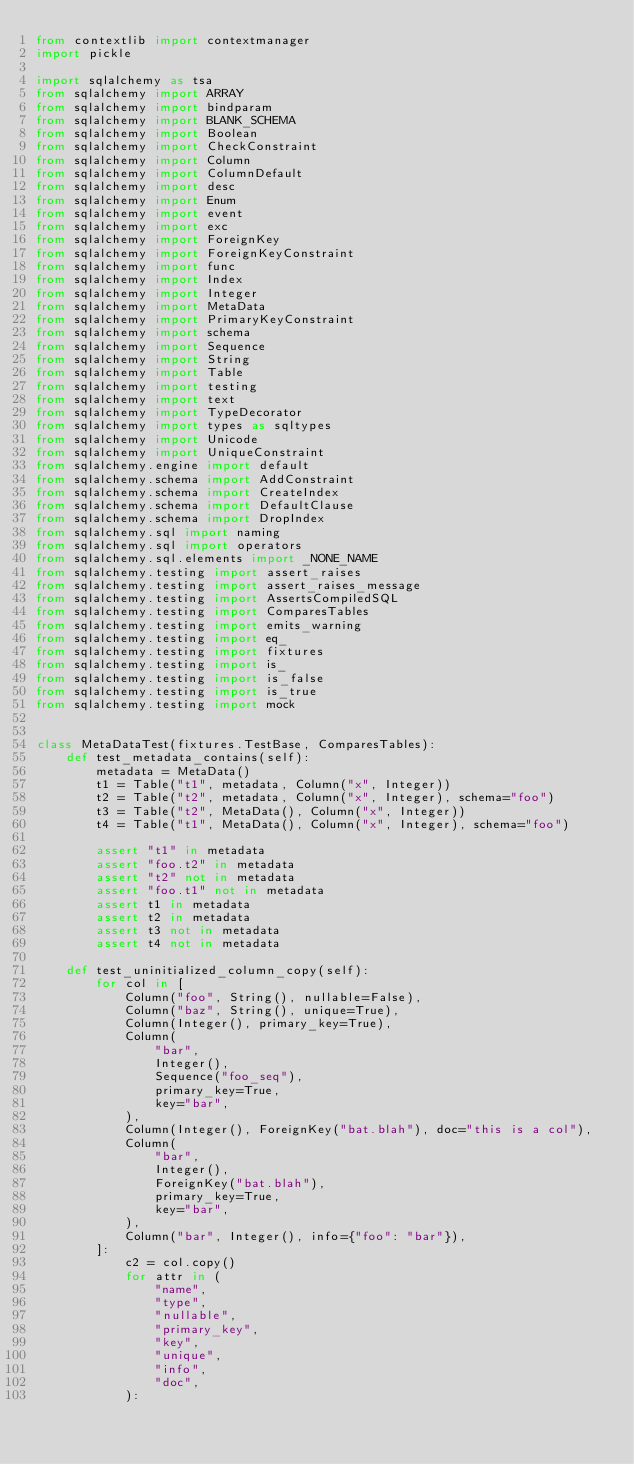<code> <loc_0><loc_0><loc_500><loc_500><_Python_>from contextlib import contextmanager
import pickle

import sqlalchemy as tsa
from sqlalchemy import ARRAY
from sqlalchemy import bindparam
from sqlalchemy import BLANK_SCHEMA
from sqlalchemy import Boolean
from sqlalchemy import CheckConstraint
from sqlalchemy import Column
from sqlalchemy import ColumnDefault
from sqlalchemy import desc
from sqlalchemy import Enum
from sqlalchemy import event
from sqlalchemy import exc
from sqlalchemy import ForeignKey
from sqlalchemy import ForeignKeyConstraint
from sqlalchemy import func
from sqlalchemy import Index
from sqlalchemy import Integer
from sqlalchemy import MetaData
from sqlalchemy import PrimaryKeyConstraint
from sqlalchemy import schema
from sqlalchemy import Sequence
from sqlalchemy import String
from sqlalchemy import Table
from sqlalchemy import testing
from sqlalchemy import text
from sqlalchemy import TypeDecorator
from sqlalchemy import types as sqltypes
from sqlalchemy import Unicode
from sqlalchemy import UniqueConstraint
from sqlalchemy.engine import default
from sqlalchemy.schema import AddConstraint
from sqlalchemy.schema import CreateIndex
from sqlalchemy.schema import DefaultClause
from sqlalchemy.schema import DropIndex
from sqlalchemy.sql import naming
from sqlalchemy.sql import operators
from sqlalchemy.sql.elements import _NONE_NAME
from sqlalchemy.testing import assert_raises
from sqlalchemy.testing import assert_raises_message
from sqlalchemy.testing import AssertsCompiledSQL
from sqlalchemy.testing import ComparesTables
from sqlalchemy.testing import emits_warning
from sqlalchemy.testing import eq_
from sqlalchemy.testing import fixtures
from sqlalchemy.testing import is_
from sqlalchemy.testing import is_false
from sqlalchemy.testing import is_true
from sqlalchemy.testing import mock


class MetaDataTest(fixtures.TestBase, ComparesTables):
    def test_metadata_contains(self):
        metadata = MetaData()
        t1 = Table("t1", metadata, Column("x", Integer))
        t2 = Table("t2", metadata, Column("x", Integer), schema="foo")
        t3 = Table("t2", MetaData(), Column("x", Integer))
        t4 = Table("t1", MetaData(), Column("x", Integer), schema="foo")

        assert "t1" in metadata
        assert "foo.t2" in metadata
        assert "t2" not in metadata
        assert "foo.t1" not in metadata
        assert t1 in metadata
        assert t2 in metadata
        assert t3 not in metadata
        assert t4 not in metadata

    def test_uninitialized_column_copy(self):
        for col in [
            Column("foo", String(), nullable=False),
            Column("baz", String(), unique=True),
            Column(Integer(), primary_key=True),
            Column(
                "bar",
                Integer(),
                Sequence("foo_seq"),
                primary_key=True,
                key="bar",
            ),
            Column(Integer(), ForeignKey("bat.blah"), doc="this is a col"),
            Column(
                "bar",
                Integer(),
                ForeignKey("bat.blah"),
                primary_key=True,
                key="bar",
            ),
            Column("bar", Integer(), info={"foo": "bar"}),
        ]:
            c2 = col.copy()
            for attr in (
                "name",
                "type",
                "nullable",
                "primary_key",
                "key",
                "unique",
                "info",
                "doc",
            ):</code> 